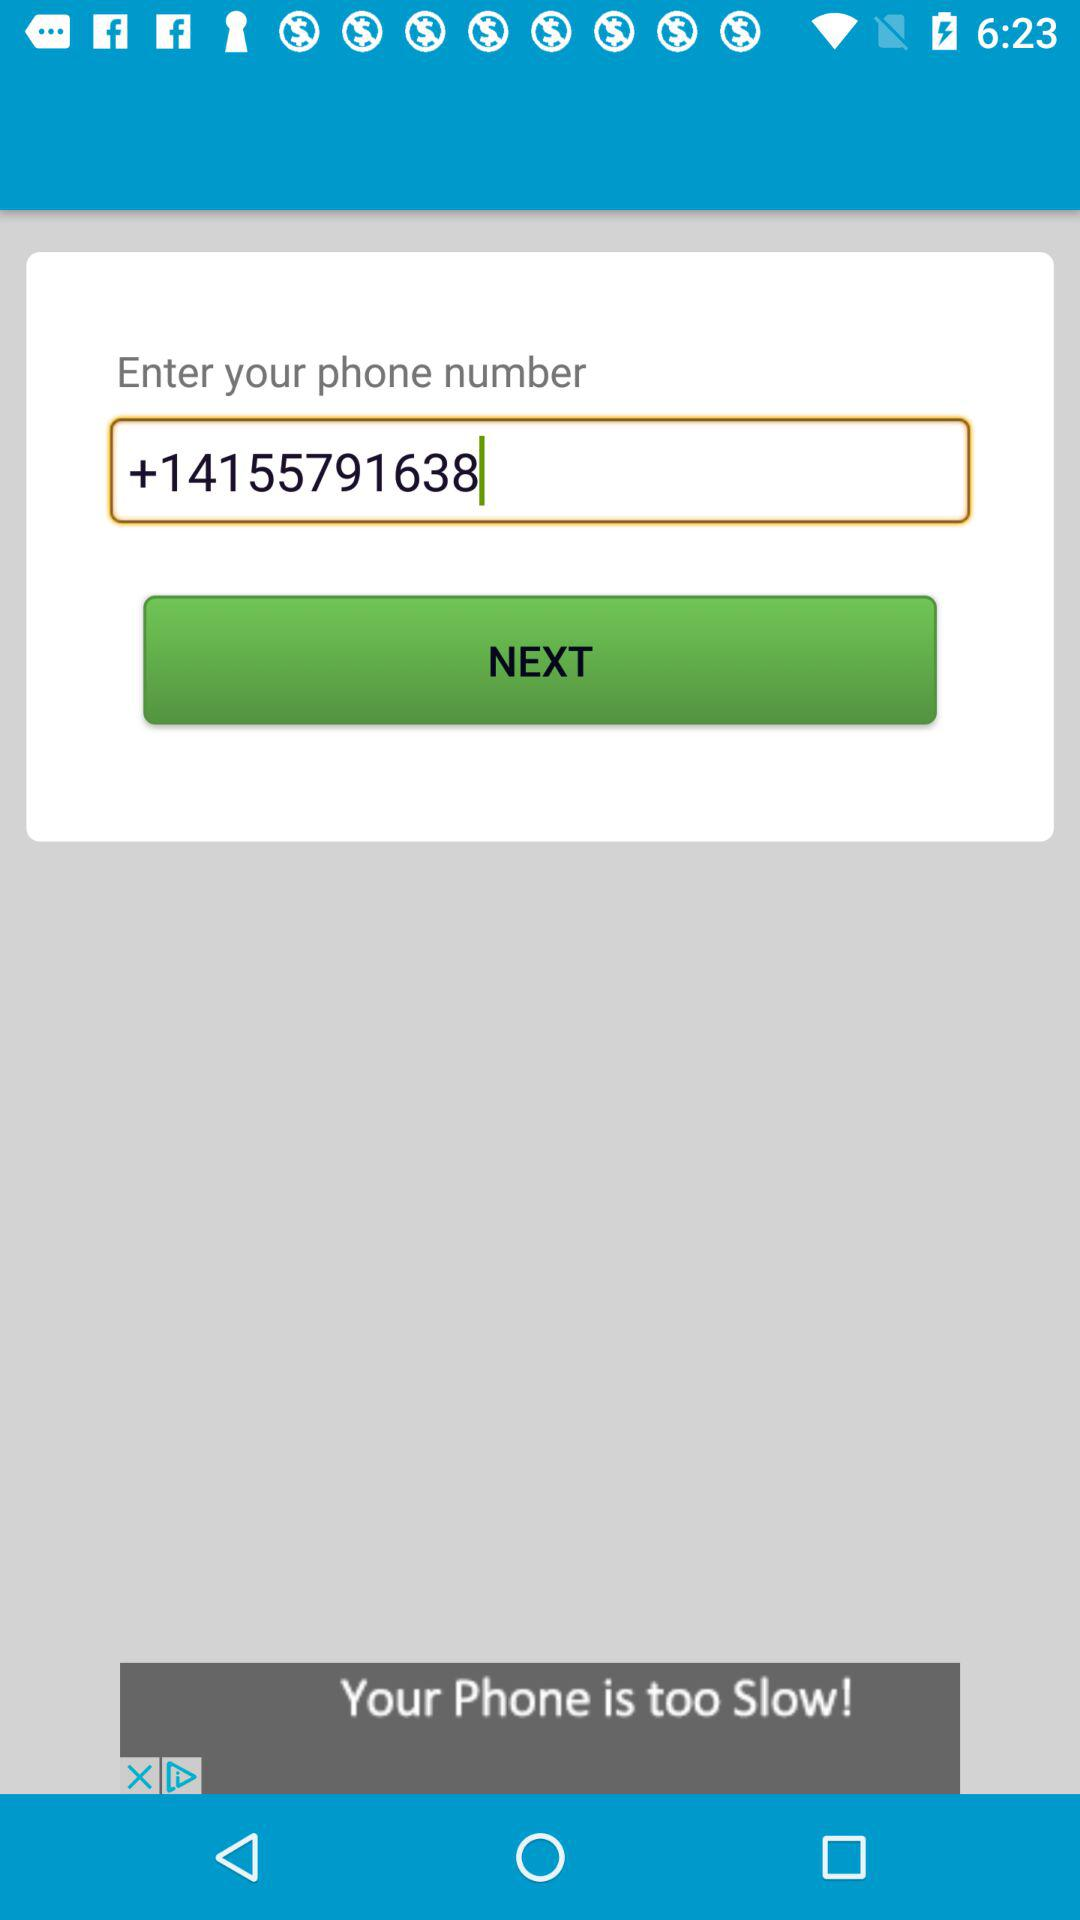What is the mobile number? The mobile number is +14155791638. 